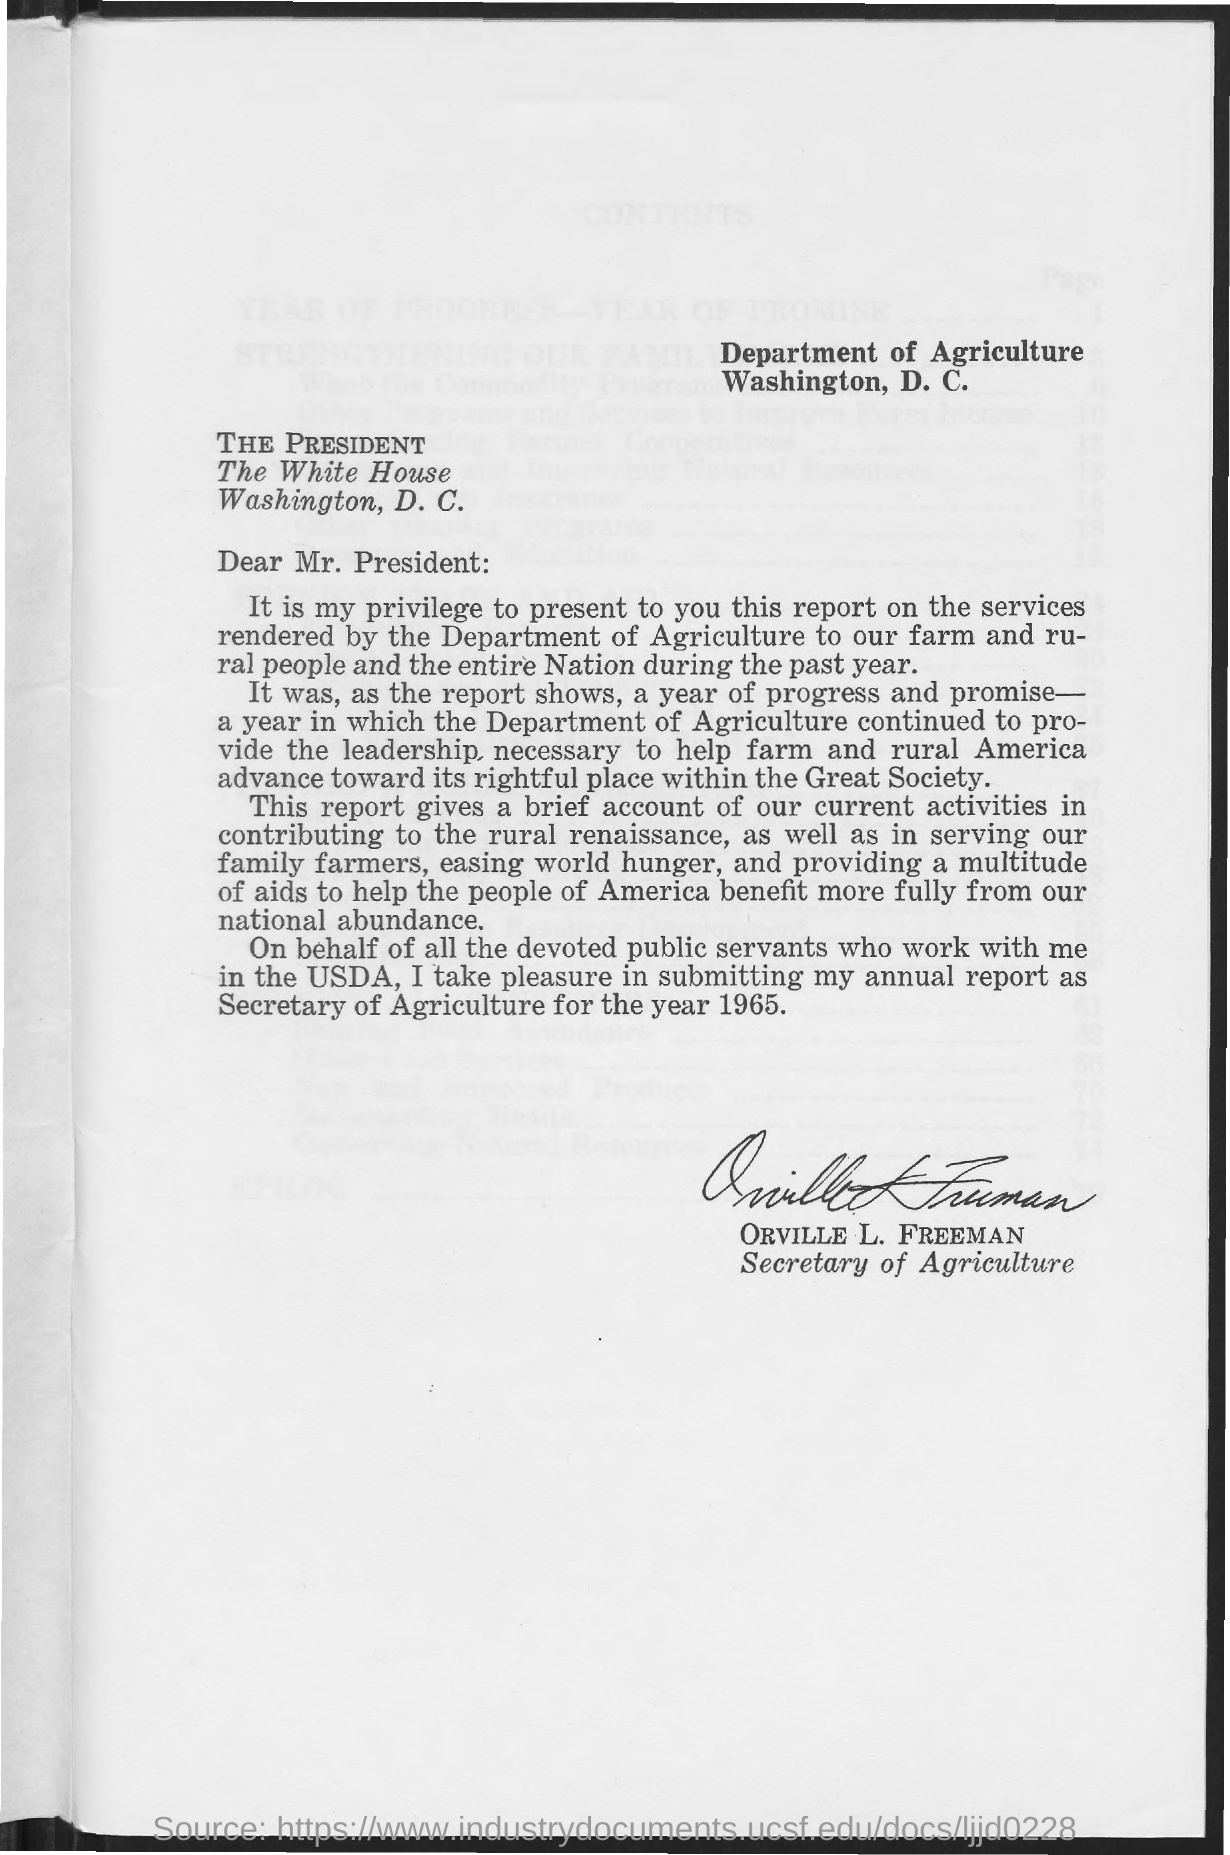Identify some key points in this picture. The letterhead mentions the Department of Agriculture. The signature on this letter is that of Orville L. Freeman. Orville L. Freeman served as the Secretary of Agriculture. 